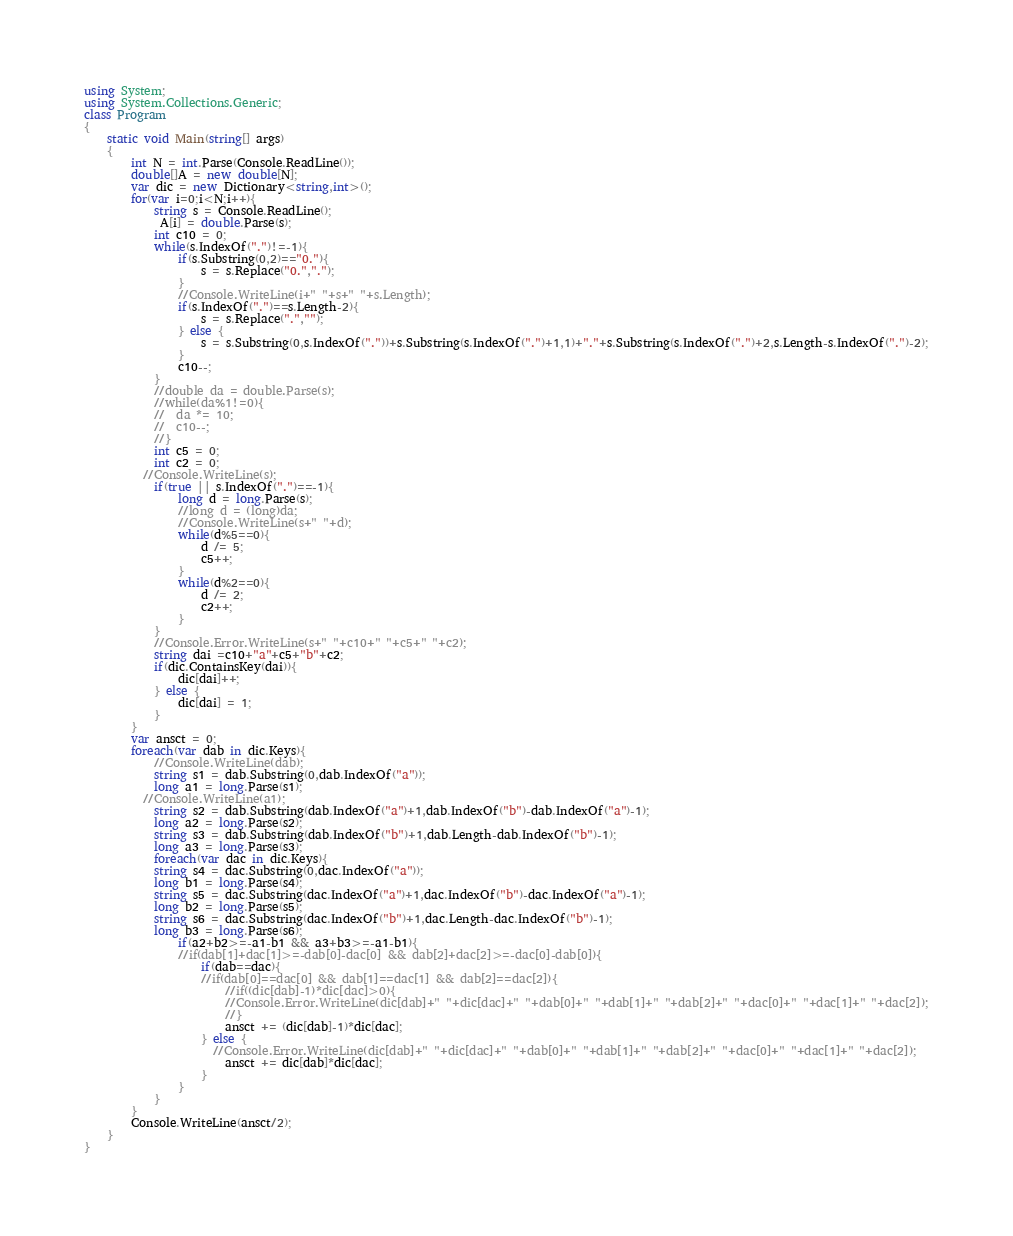<code> <loc_0><loc_0><loc_500><loc_500><_C#_>using System;
using System.Collections.Generic;
class Program
{
	static void Main(string[] args)
	{
		int N = int.Parse(Console.ReadLine());
		double[]A = new double[N];
		var dic = new Dictionary<string,int>();
		for(var i=0;i<N;i++){
			string s = Console.ReadLine();
             A[i] = double.Parse(s);
			int c10 = 0;
          	while(s.IndexOf(".")!=-1){
				if(s.Substring(0,2)=="0."){
                  	s = s.Replace("0.",".");
                }
 				//Console.WriteLine(i+" "+s+" "+s.Length);
				if(s.IndexOf(".")==s.Length-2){
                  	s = s.Replace(".","");
                } else {
                    s = s.Substring(0,s.IndexOf("."))+s.Substring(s.IndexOf(".")+1,1)+"."+s.Substring(s.IndexOf(".")+2,s.Length-s.IndexOf(".")-2);
                }
              	c10--;
            }
			//double da = double.Parse(s);
			//while(da%1!=0){
			//	da *= 10;
			//	c10--;
			//}
			int c5 = 0;
			int c2 = 0;
          //Console.WriteLine(s);
			if(true || s.IndexOf(".")==-1){
              	long d = long.Parse(s);
				//long d = (long)da;
              	//Console.WriteLine(s+" "+d);
				while(d%5==0){
					d /= 5;
					c5++;
				}
				while(d%2==0){
					d /= 2;
					c2++;
				}
			}
			//Console.Error.WriteLine(s+" "+c10+" "+c5+" "+c2);
			string dai =c10+"a"+c5+"b"+c2;
			if(dic.ContainsKey(dai)){
              	dic[dai]++;
            } else {
              	dic[dai] = 1;
            }
		}
      	var ansct = 0;
		foreach(var dab in dic.Keys){
          	//Console.WriteLine(dab);
 			string s1 = dab.Substring(0,dab.IndexOf("a"));
          	long a1 = long.Parse(s1);
          //Console.WriteLine(a1);
 			string s2 = dab.Substring(dab.IndexOf("a")+1,dab.IndexOf("b")-dab.IndexOf("a")-1);
          	long a2 = long.Parse(s2);
 			string s3 = dab.Substring(dab.IndexOf("b")+1,dab.Length-dab.IndexOf("b")-1);
          	long a3 = long.Parse(s3);
			foreach(var dac in dic.Keys){
 			string s4 = dac.Substring(0,dac.IndexOf("a"));
          	long b1 = long.Parse(s4);
 			string s5 = dac.Substring(dac.IndexOf("a")+1,dac.IndexOf("b")-dac.IndexOf("a")-1);
          	long b2 = long.Parse(s5);
 			string s6 = dac.Substring(dac.IndexOf("b")+1,dac.Length-dac.IndexOf("b")-1);
          	long b3 = long.Parse(s6);
              	if(a2+b2>=-a1-b1 && a3+b3>=-a1-b1){
				//if(dab[1]+dac[1]>=-dab[0]-dac[0] && dab[2]+dac[2]>=-dac[0]-dab[0]){
 	                if(dab==dac){
                  	//if(dab[0]==dac[0] && dab[1]==dac[1] && dab[2]==dac[2]){
                      	//if((dic[dab]-1)*dic[dac]>0){
                      	//Console.Error.WriteLine(dic[dab]+" "+dic[dac]+" "+dab[0]+" "+dab[1]+" "+dab[2]+" "+dac[0]+" "+dac[1]+" "+dac[2]);
                        //}
                      	ansct += (dic[dab]-1)*dic[dac];
                    } else {
                      //Console.Error.WriteLine(dic[dab]+" "+dic[dac]+" "+dab[0]+" "+dab[1]+" "+dab[2]+" "+dac[0]+" "+dac[1]+" "+dac[2]);
	                 	ansct += dic[dab]*dic[dac];
                    }
                }
            }
        }
		Console.WriteLine(ansct/2);
	}
}
</code> 